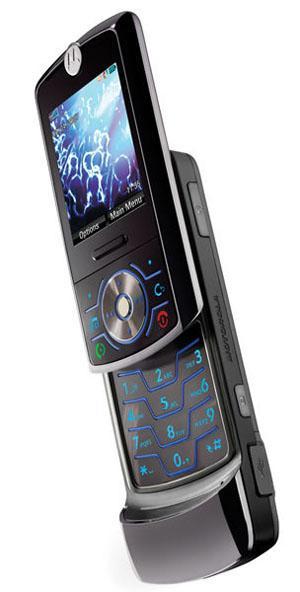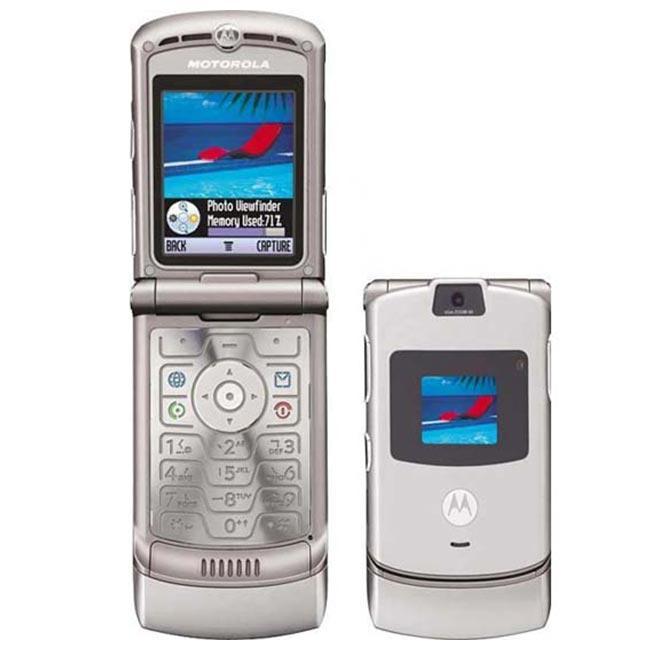The first image is the image on the left, the second image is the image on the right. Analyze the images presented: Is the assertion "The left image contains one diagonally-displayed black phone with a picture on its screen and its front slid partly up to reveal its keypad." valid? Answer yes or no. Yes. The first image is the image on the left, the second image is the image on the right. For the images shown, is this caption "There are at least three phones side by side in one of the pictures." true? Answer yes or no. No. 